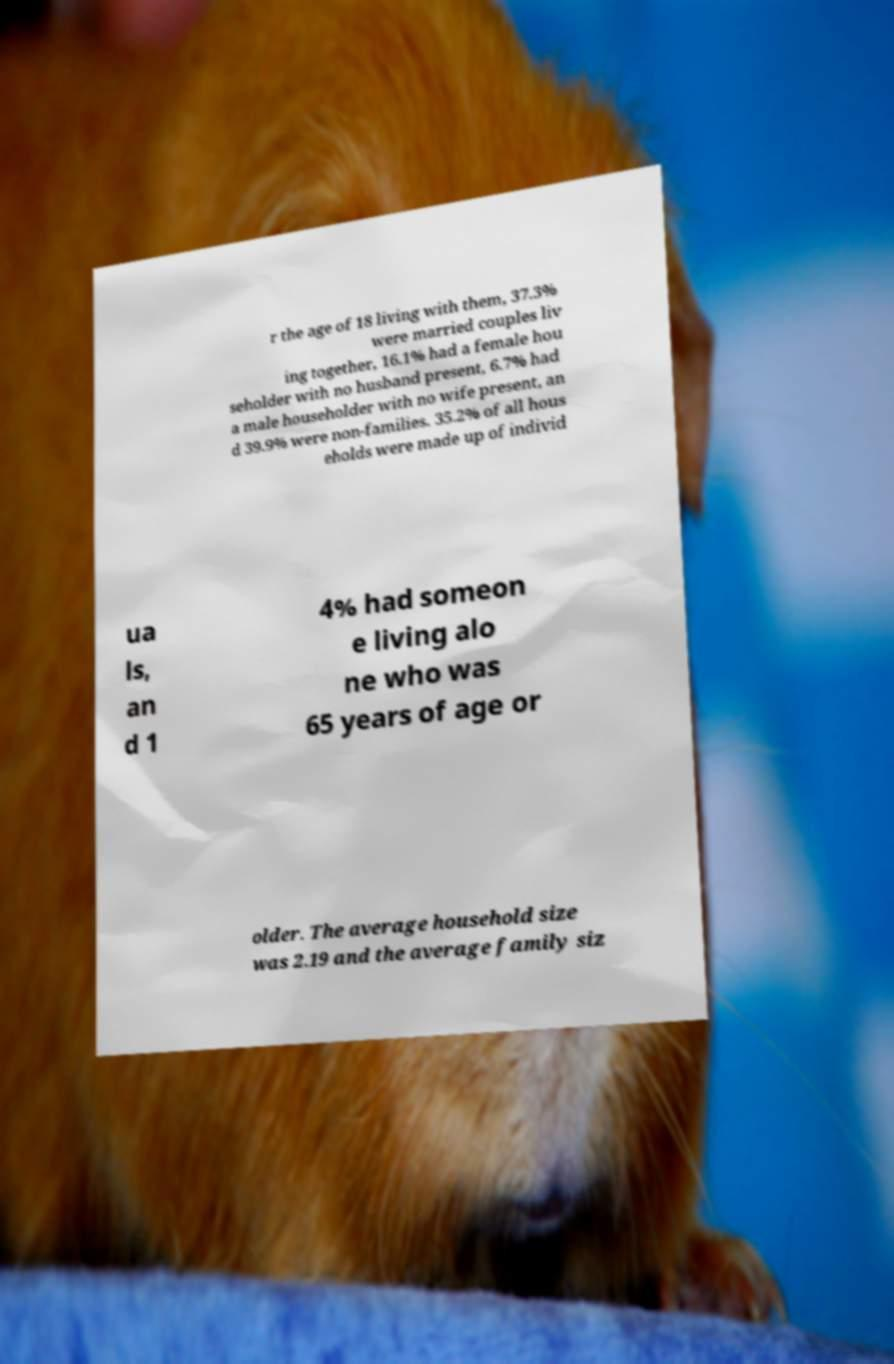Can you read and provide the text displayed in the image?This photo seems to have some interesting text. Can you extract and type it out for me? r the age of 18 living with them, 37.3% were married couples liv ing together, 16.1% had a female hou seholder with no husband present, 6.7% had a male householder with no wife present, an d 39.9% were non-families. 35.2% of all hous eholds were made up of individ ua ls, an d 1 4% had someon e living alo ne who was 65 years of age or older. The average household size was 2.19 and the average family siz 